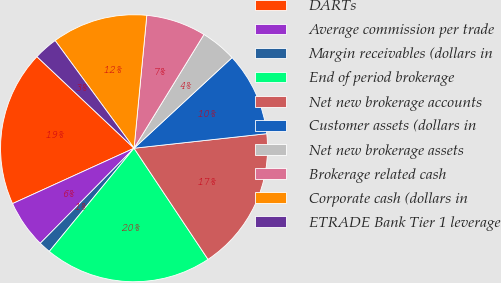<chart> <loc_0><loc_0><loc_500><loc_500><pie_chart><fcel>DARTs<fcel>Average commission per trade<fcel>Margin receivables (dollars in<fcel>End of period brokerage<fcel>Net new brokerage accounts<fcel>Customer assets (dollars in<fcel>Net new brokerage assets<fcel>Brokerage related cash<fcel>Corporate cash (dollars in<fcel>ETRADE Bank Tier 1 leverage<nl><fcel>18.84%<fcel>5.8%<fcel>1.45%<fcel>20.29%<fcel>17.39%<fcel>10.14%<fcel>4.35%<fcel>7.25%<fcel>11.59%<fcel>2.9%<nl></chart> 